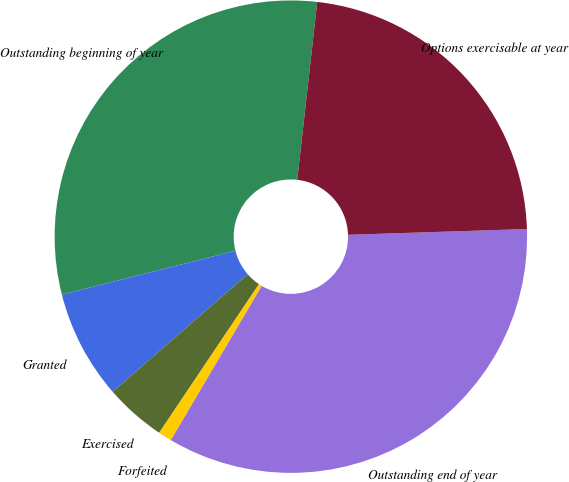Convert chart to OTSL. <chart><loc_0><loc_0><loc_500><loc_500><pie_chart><fcel>Outstanding beginning of year<fcel>Granted<fcel>Exercised<fcel>Forfeited<fcel>Outstanding end of year<fcel>Options exercisable at year<nl><fcel>30.73%<fcel>7.45%<fcel>4.19%<fcel>0.93%<fcel>33.99%<fcel>22.7%<nl></chart> 